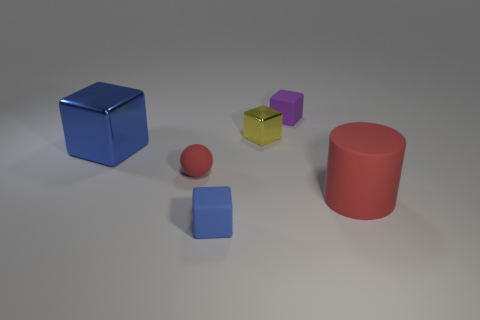Subtract 1 blocks. How many blocks are left? 3 Subtract all red cubes. Subtract all yellow balls. How many cubes are left? 4 Add 1 cyan shiny spheres. How many objects exist? 7 Subtract all blocks. How many objects are left? 2 Add 6 big blue things. How many big blue things are left? 7 Add 4 shiny cubes. How many shiny cubes exist? 6 Subtract 0 gray cylinders. How many objects are left? 6 Subtract all rubber blocks. Subtract all tiny metal blocks. How many objects are left? 3 